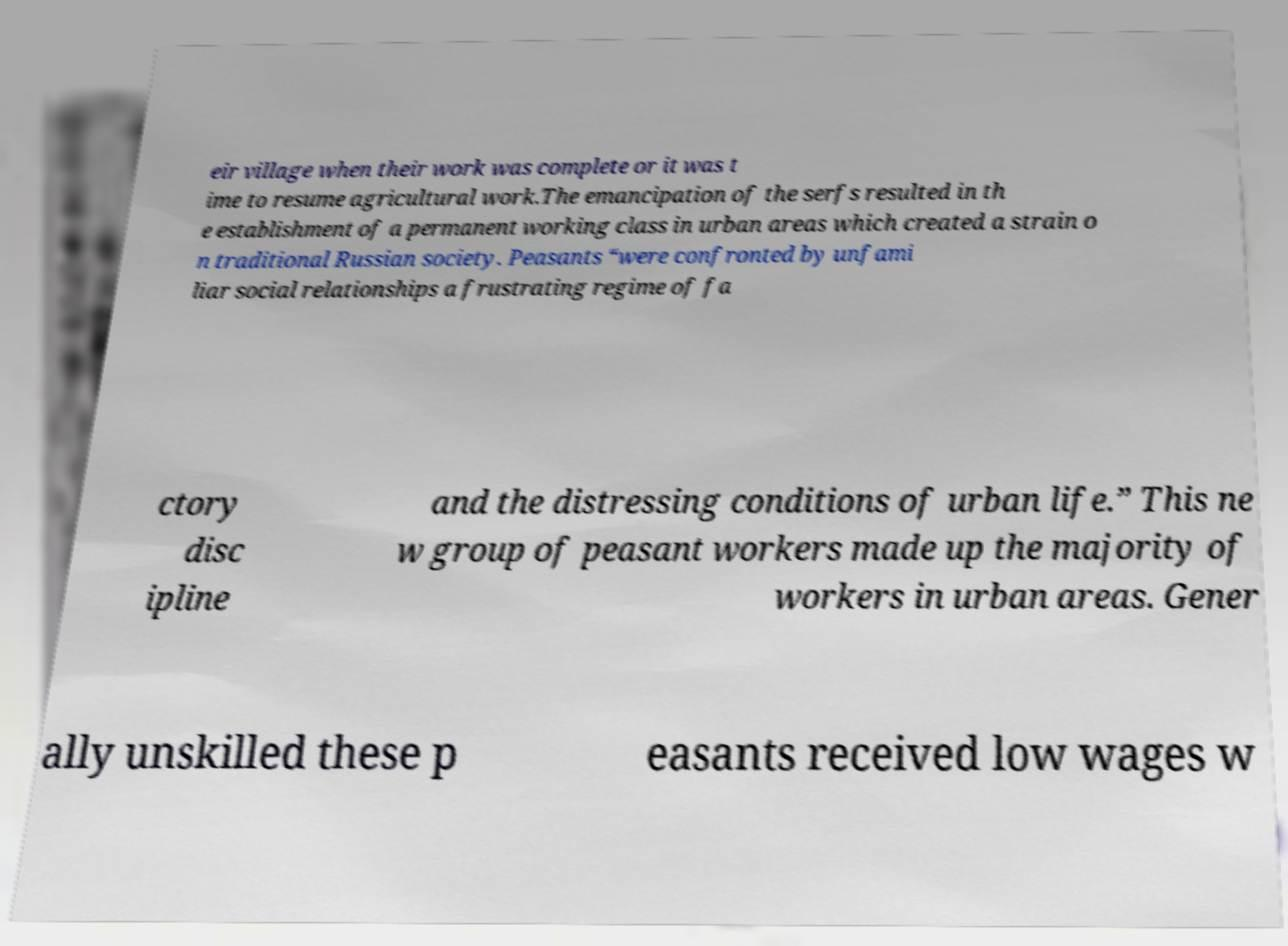I need the written content from this picture converted into text. Can you do that? eir village when their work was complete or it was t ime to resume agricultural work.The emancipation of the serfs resulted in th e establishment of a permanent working class in urban areas which created a strain o n traditional Russian society. Peasants “were confronted by unfami liar social relationships a frustrating regime of fa ctory disc ipline and the distressing conditions of urban life.” This ne w group of peasant workers made up the majority of workers in urban areas. Gener ally unskilled these p easants received low wages w 